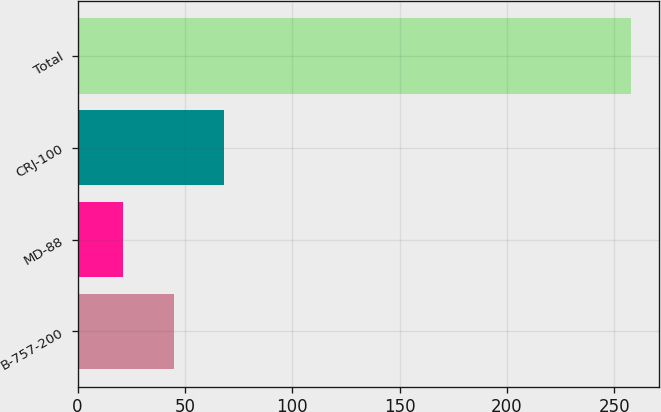Convert chart to OTSL. <chart><loc_0><loc_0><loc_500><loc_500><bar_chart><fcel>B-757-200<fcel>MD-88<fcel>CRJ-100<fcel>Total<nl><fcel>44.7<fcel>21<fcel>68.4<fcel>258<nl></chart> 